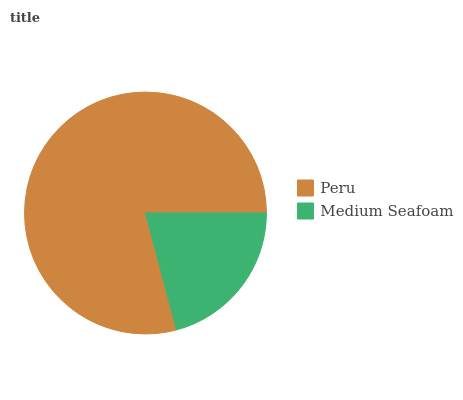Is Medium Seafoam the minimum?
Answer yes or no. Yes. Is Peru the maximum?
Answer yes or no. Yes. Is Medium Seafoam the maximum?
Answer yes or no. No. Is Peru greater than Medium Seafoam?
Answer yes or no. Yes. Is Medium Seafoam less than Peru?
Answer yes or no. Yes. Is Medium Seafoam greater than Peru?
Answer yes or no. No. Is Peru less than Medium Seafoam?
Answer yes or no. No. Is Peru the high median?
Answer yes or no. Yes. Is Medium Seafoam the low median?
Answer yes or no. Yes. Is Medium Seafoam the high median?
Answer yes or no. No. Is Peru the low median?
Answer yes or no. No. 